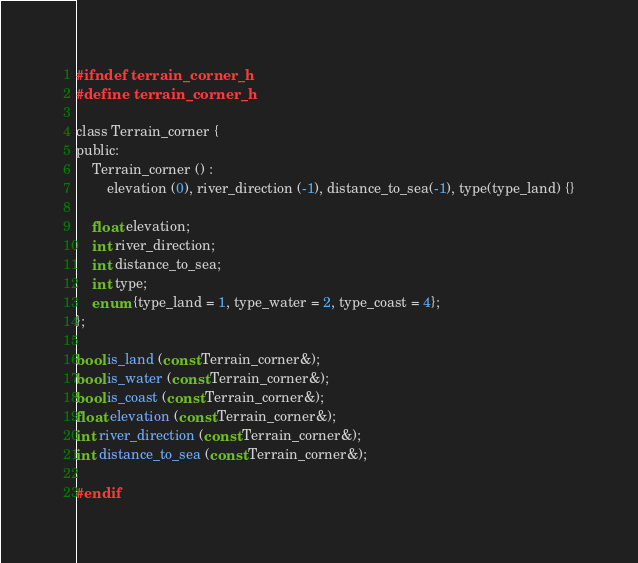<code> <loc_0><loc_0><loc_500><loc_500><_C_>#ifndef terrain_corner_h
#define terrain_corner_h

class Terrain_corner {
public:
	Terrain_corner () :
		elevation (0), river_direction (-1), distance_to_sea(-1), type(type_land) {}

	float elevation;
	int river_direction;
	int distance_to_sea;
	int type;
	enum {type_land = 1, type_water = 2, type_coast = 4};
};

bool is_land (const Terrain_corner&);
bool is_water (const Terrain_corner&);
bool is_coast (const Terrain_corner&);
float elevation (const Terrain_corner&);
int river_direction (const Terrain_corner&);
int distance_to_sea (const Terrain_corner&);

#endif
</code> 